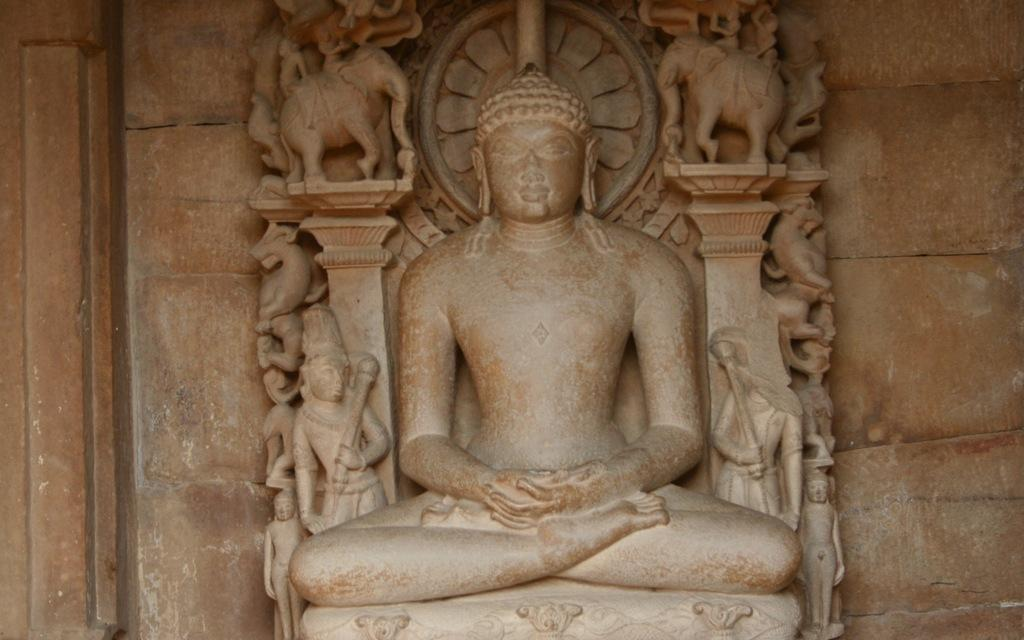What type of artwork can be seen in the image? There are sculptures in the image. What else is visible in the image besides the sculptures? There is a wall in the image. Who is the owner of the neck in the image? There is no reference to a neck or an owner in the image, as it features sculptures and a wall. 